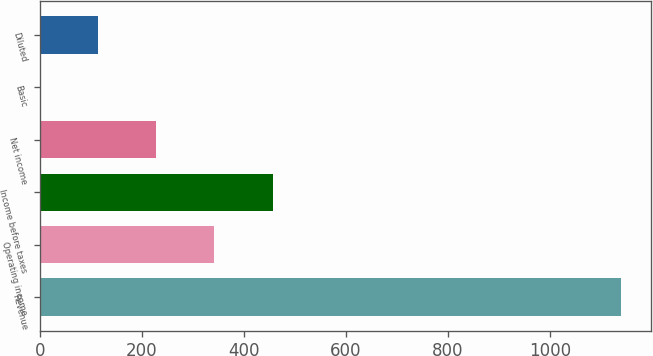Convert chart. <chart><loc_0><loc_0><loc_500><loc_500><bar_chart><fcel>Revenue<fcel>Operating income<fcel>Income before taxes<fcel>Net income<fcel>Basic<fcel>Diluted<nl><fcel>1140.3<fcel>342.57<fcel>456.53<fcel>228.61<fcel>0.69<fcel>114.65<nl></chart> 